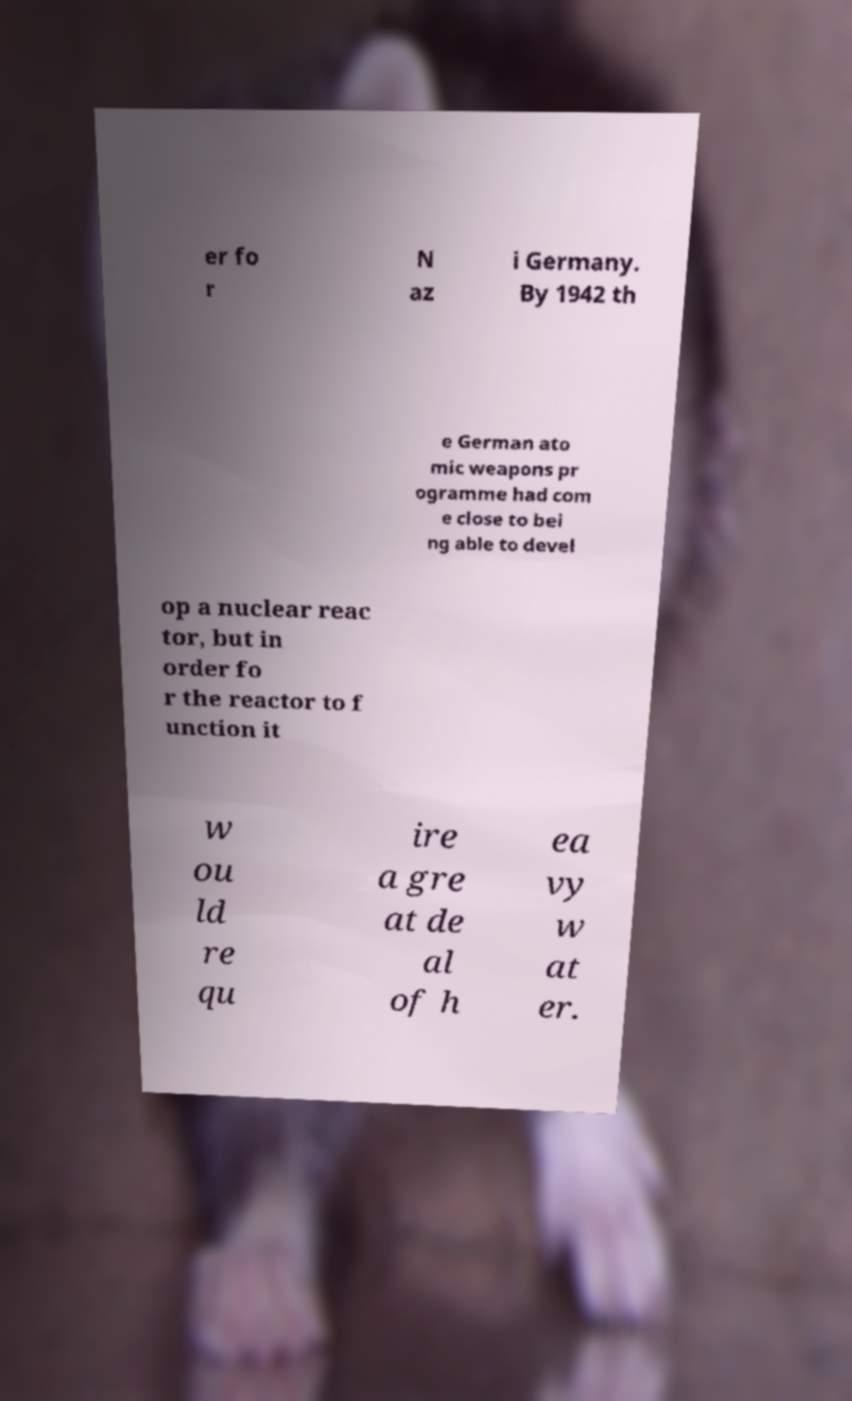Can you read and provide the text displayed in the image?This photo seems to have some interesting text. Can you extract and type it out for me? er fo r N az i Germany. By 1942 th e German ato mic weapons pr ogramme had com e close to bei ng able to devel op a nuclear reac tor, but in order fo r the reactor to f unction it w ou ld re qu ire a gre at de al of h ea vy w at er. 